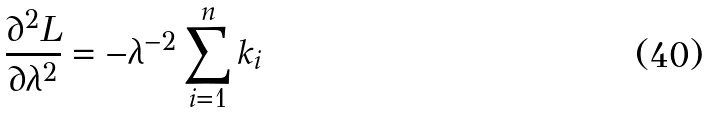<formula> <loc_0><loc_0><loc_500><loc_500>\frac { \partial ^ { 2 } L } { \partial \lambda ^ { 2 } } = - \lambda ^ { - 2 } \sum _ { i = 1 } ^ { n } k _ { i }</formula> 